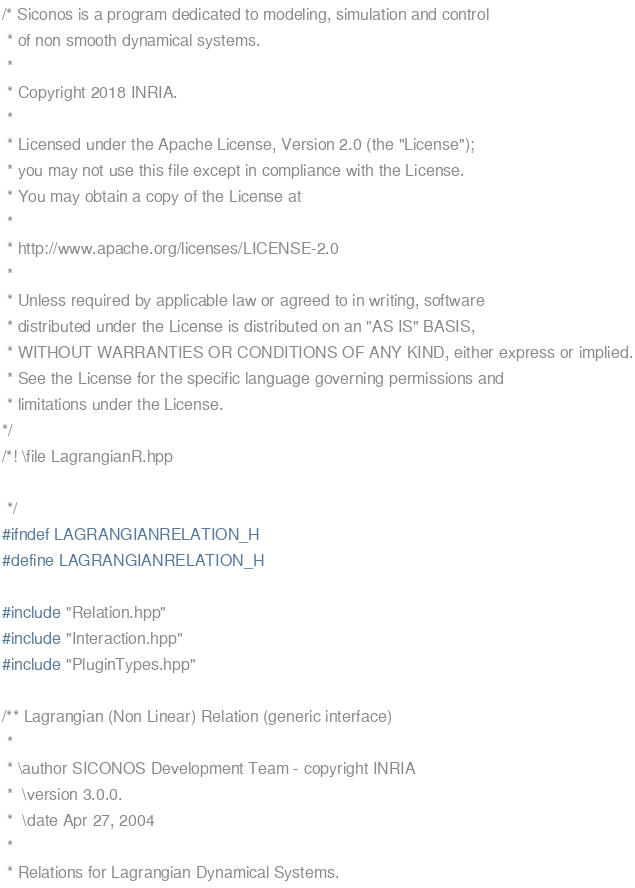<code> <loc_0><loc_0><loc_500><loc_500><_C++_>/* Siconos is a program dedicated to modeling, simulation and control
 * of non smooth dynamical systems.
 *
 * Copyright 2018 INRIA.
 *
 * Licensed under the Apache License, Version 2.0 (the "License");
 * you may not use this file except in compliance with the License.
 * You may obtain a copy of the License at
 *
 * http://www.apache.org/licenses/LICENSE-2.0
 *
 * Unless required by applicable law or agreed to in writing, software
 * distributed under the License is distributed on an "AS IS" BASIS,
 * WITHOUT WARRANTIES OR CONDITIONS OF ANY KIND, either express or implied.
 * See the License for the specific language governing permissions and
 * limitations under the License.
*/
/*! \file LagrangianR.hpp

 */
#ifndef LAGRANGIANRELATION_H
#define LAGRANGIANRELATION_H

#include "Relation.hpp"
#include "Interaction.hpp"
#include "PluginTypes.hpp"

/** Lagrangian (Non Linear) Relation (generic interface)
 *
 * \author SICONOS Development Team - copyright INRIA
 *  \version 3.0.0.
 *  \date Apr 27, 2004
 *
 * Relations for Lagrangian Dynamical Systems.</code> 